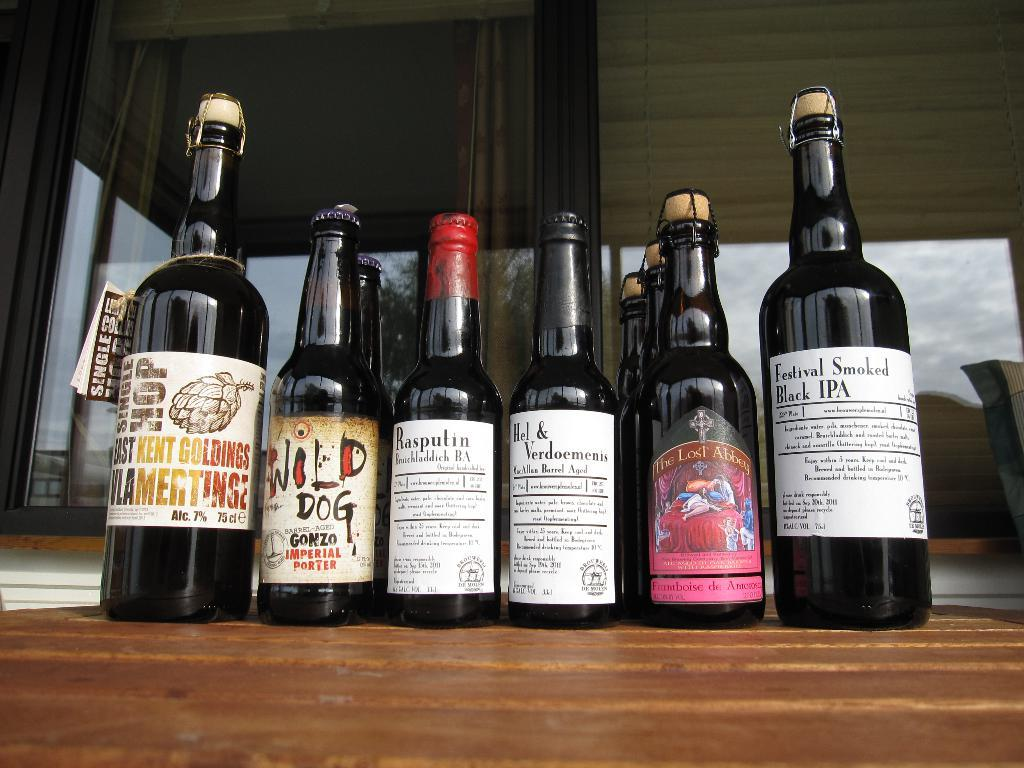What objects are on the table in the image? There are bottles on the table in the image. Can you describe the bottles in more detail? Unfortunately, the provided facts do not give any additional information about the bottles. What might be the purpose of the bottles on the table? The purpose of the bottles on the table is not clear from the given facts. How many butterflies are sitting on the bottles in the image? There is no mention of butterflies in the provided facts, so we cannot answer this question. 